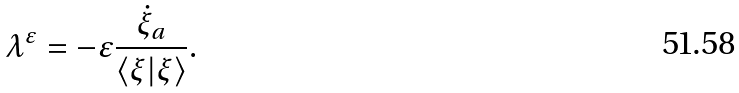<formula> <loc_0><loc_0><loc_500><loc_500>\lambda ^ { \varepsilon } = - \varepsilon \frac { \dot { \xi } _ { a } } { \langle \xi | \xi \rangle } .</formula> 